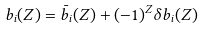Convert formula to latex. <formula><loc_0><loc_0><loc_500><loc_500>b _ { i } ( Z ) = \bar { b } _ { i } ( Z ) + ( - 1 ) ^ { Z } \delta b _ { i } ( Z )</formula> 